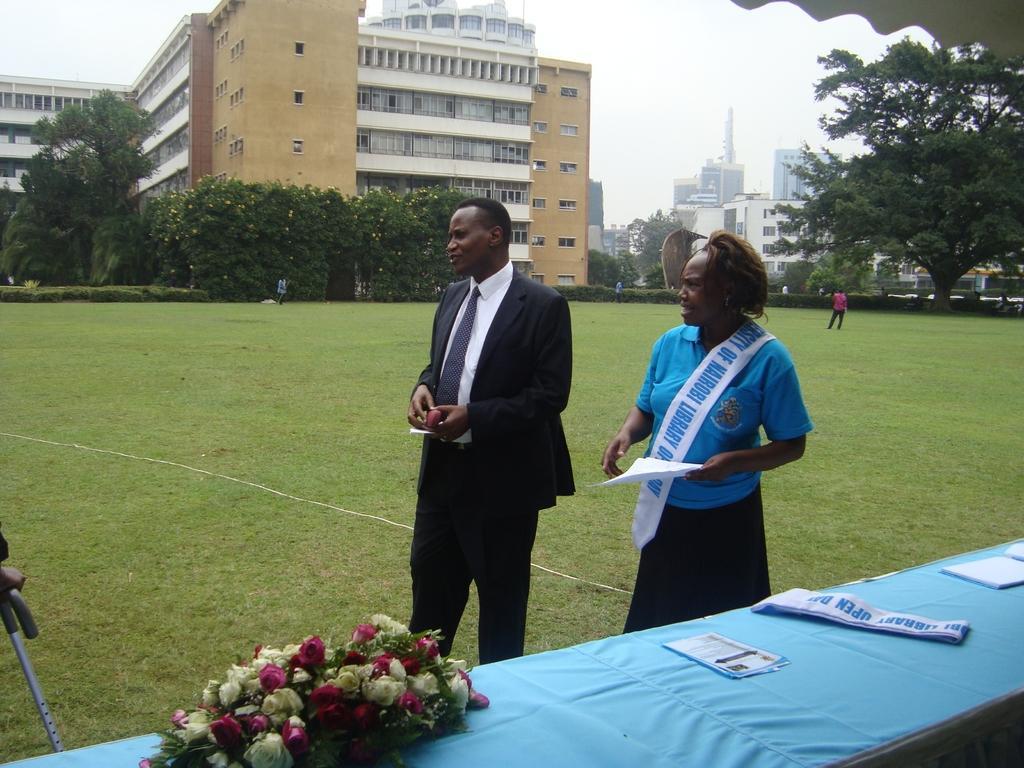Can you describe this image briefly? As we can see in the image there is grass, trees, buildings, flowers, few people here and there and a table. On the top there is sky. 